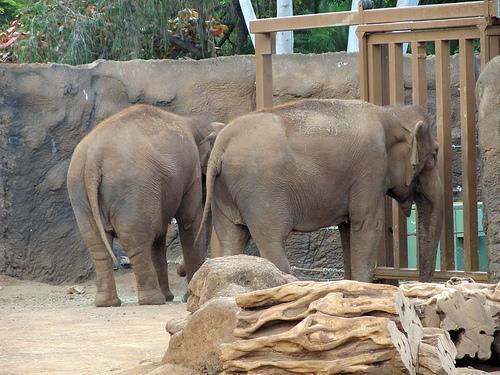How many elephants can be seen in the picture?
Give a very brief answer. 2. 